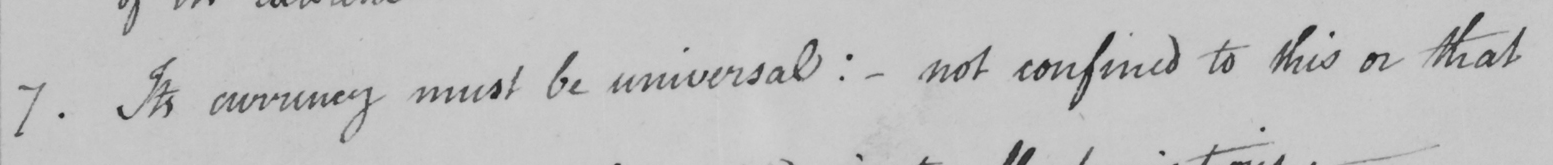Transcribe the text shown in this historical manuscript line. 7 . Its currency must be universal :   _  not confined to this or that 